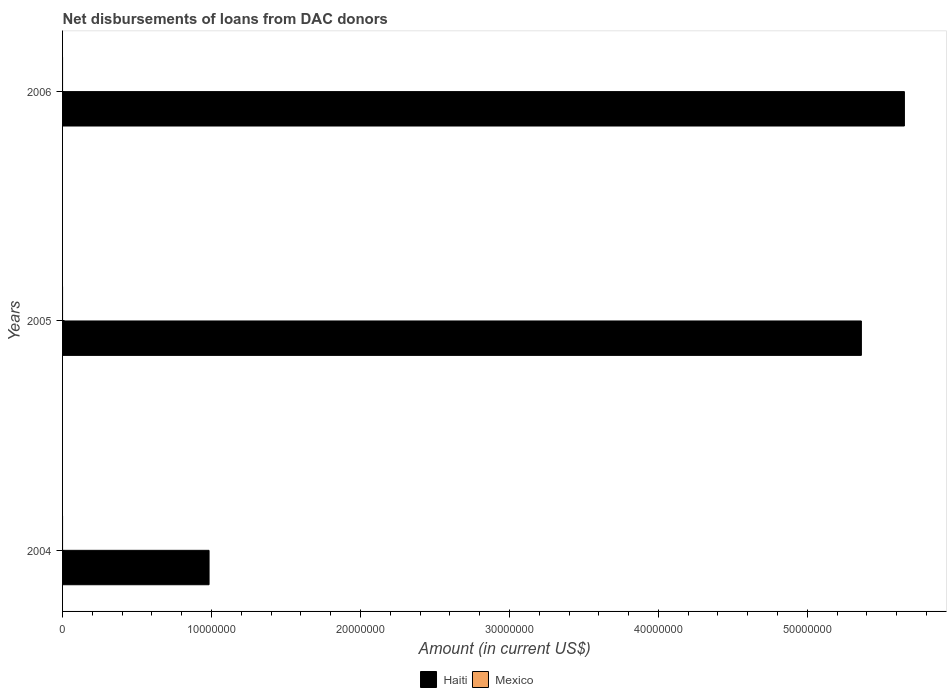How many different coloured bars are there?
Ensure brevity in your answer.  1. Are the number of bars on each tick of the Y-axis equal?
Ensure brevity in your answer.  Yes. How many bars are there on the 2nd tick from the top?
Your answer should be compact. 1. What is the label of the 1st group of bars from the top?
Ensure brevity in your answer.  2006. In how many cases, is the number of bars for a given year not equal to the number of legend labels?
Your answer should be very brief. 3. What is the amount of loans disbursed in Haiti in 2006?
Ensure brevity in your answer.  5.65e+07. Across all years, what is the maximum amount of loans disbursed in Haiti?
Ensure brevity in your answer.  5.65e+07. Across all years, what is the minimum amount of loans disbursed in Haiti?
Your answer should be compact. 9.84e+06. What is the total amount of loans disbursed in Haiti in the graph?
Your answer should be compact. 1.20e+08. What is the difference between the amount of loans disbursed in Haiti in 2005 and that in 2006?
Your response must be concise. -2.89e+06. What is the difference between the amount of loans disbursed in Haiti in 2004 and the amount of loans disbursed in Mexico in 2005?
Offer a very short reply. 9.84e+06. What is the average amount of loans disbursed in Haiti per year?
Your response must be concise. 4.00e+07. In how many years, is the amount of loans disbursed in Mexico greater than 12000000 US$?
Make the answer very short. 0. What is the ratio of the amount of loans disbursed in Haiti in 2004 to that in 2006?
Provide a short and direct response. 0.17. What is the difference between the highest and the second highest amount of loans disbursed in Haiti?
Keep it short and to the point. 2.89e+06. What is the difference between the highest and the lowest amount of loans disbursed in Haiti?
Offer a terse response. 4.67e+07. In how many years, is the amount of loans disbursed in Haiti greater than the average amount of loans disbursed in Haiti taken over all years?
Make the answer very short. 2. Is the sum of the amount of loans disbursed in Haiti in 2004 and 2005 greater than the maximum amount of loans disbursed in Mexico across all years?
Provide a succinct answer. Yes. How many bars are there?
Ensure brevity in your answer.  3. Are all the bars in the graph horizontal?
Your response must be concise. Yes. What is the difference between two consecutive major ticks on the X-axis?
Offer a very short reply. 1.00e+07. Are the values on the major ticks of X-axis written in scientific E-notation?
Provide a short and direct response. No. Does the graph contain any zero values?
Provide a succinct answer. Yes. Does the graph contain grids?
Your response must be concise. No. Where does the legend appear in the graph?
Provide a succinct answer. Bottom center. How are the legend labels stacked?
Ensure brevity in your answer.  Horizontal. What is the title of the graph?
Offer a terse response. Net disbursements of loans from DAC donors. Does "Trinidad and Tobago" appear as one of the legend labels in the graph?
Give a very brief answer. No. What is the Amount (in current US$) in Haiti in 2004?
Provide a succinct answer. 9.84e+06. What is the Amount (in current US$) of Mexico in 2004?
Provide a short and direct response. 0. What is the Amount (in current US$) in Haiti in 2005?
Provide a succinct answer. 5.36e+07. What is the Amount (in current US$) in Haiti in 2006?
Keep it short and to the point. 5.65e+07. Across all years, what is the maximum Amount (in current US$) in Haiti?
Your response must be concise. 5.65e+07. Across all years, what is the minimum Amount (in current US$) of Haiti?
Your answer should be compact. 9.84e+06. What is the total Amount (in current US$) of Haiti in the graph?
Ensure brevity in your answer.  1.20e+08. What is the total Amount (in current US$) of Mexico in the graph?
Provide a succinct answer. 0. What is the difference between the Amount (in current US$) in Haiti in 2004 and that in 2005?
Your answer should be compact. -4.38e+07. What is the difference between the Amount (in current US$) of Haiti in 2004 and that in 2006?
Offer a terse response. -4.67e+07. What is the difference between the Amount (in current US$) in Haiti in 2005 and that in 2006?
Provide a succinct answer. -2.89e+06. What is the average Amount (in current US$) of Haiti per year?
Your answer should be very brief. 4.00e+07. What is the average Amount (in current US$) of Mexico per year?
Your answer should be very brief. 0. What is the ratio of the Amount (in current US$) in Haiti in 2004 to that in 2005?
Offer a very short reply. 0.18. What is the ratio of the Amount (in current US$) in Haiti in 2004 to that in 2006?
Give a very brief answer. 0.17. What is the ratio of the Amount (in current US$) of Haiti in 2005 to that in 2006?
Provide a short and direct response. 0.95. What is the difference between the highest and the second highest Amount (in current US$) in Haiti?
Give a very brief answer. 2.89e+06. What is the difference between the highest and the lowest Amount (in current US$) of Haiti?
Ensure brevity in your answer.  4.67e+07. 